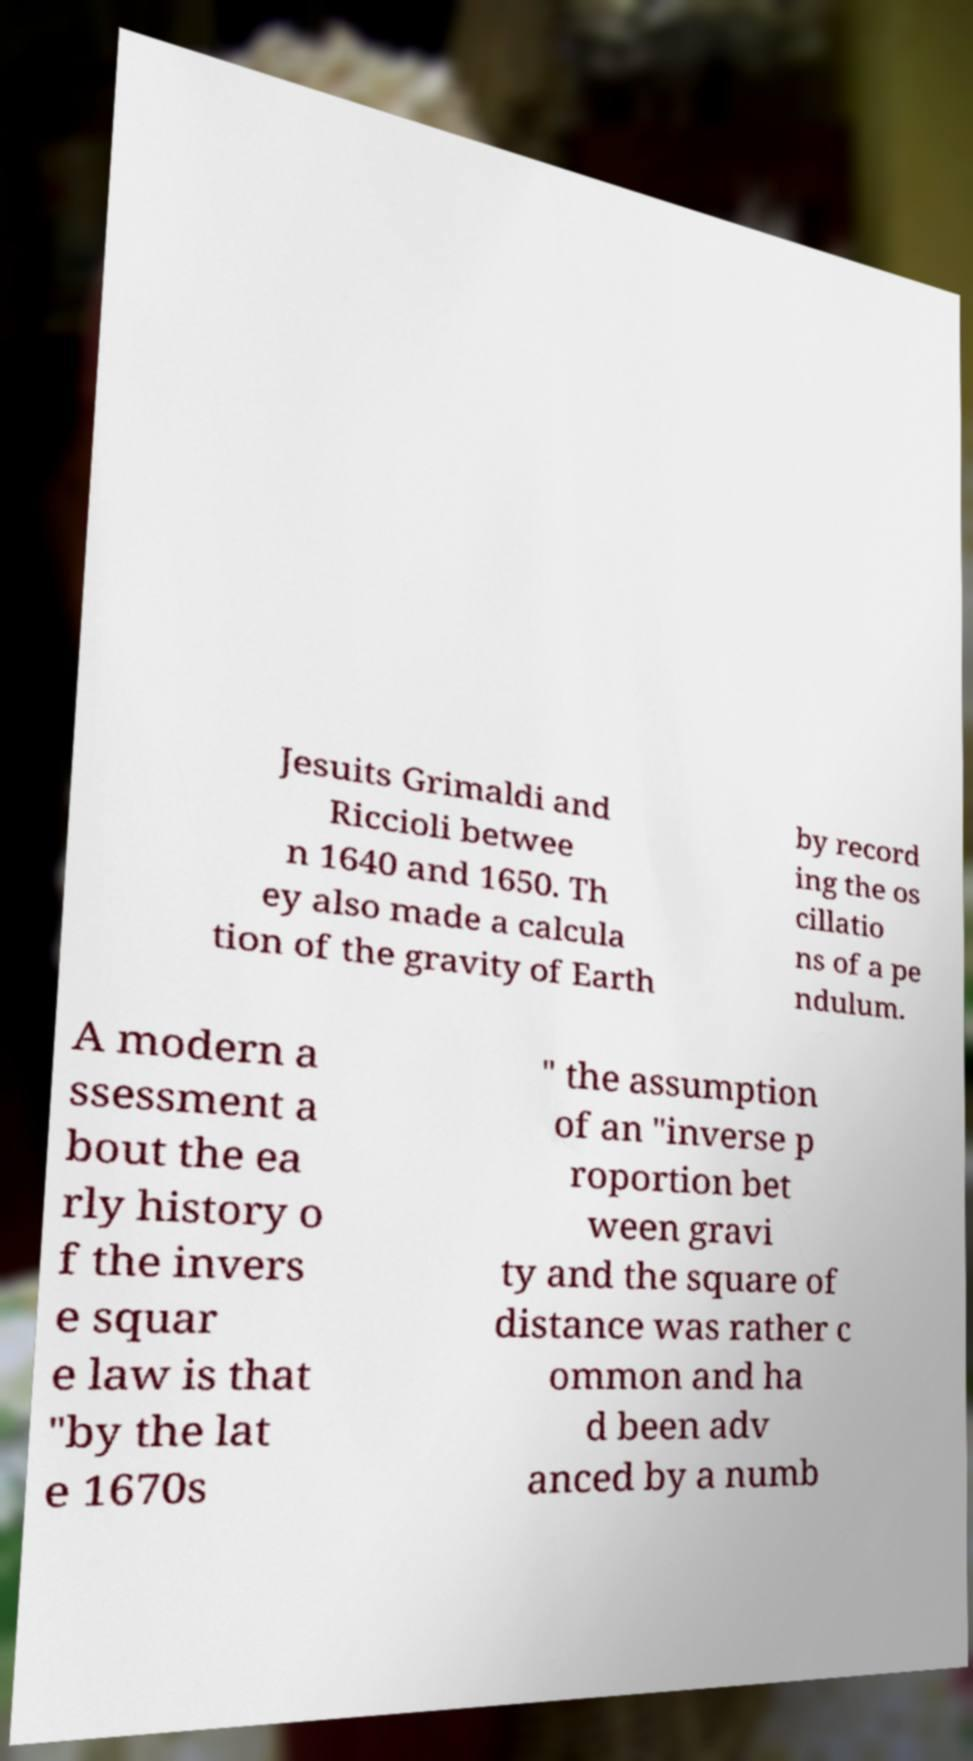Please identify and transcribe the text found in this image. Jesuits Grimaldi and Riccioli betwee n 1640 and 1650. Th ey also made a calcula tion of the gravity of Earth by record ing the os cillatio ns of a pe ndulum. A modern a ssessment a bout the ea rly history o f the invers e squar e law is that "by the lat e 1670s " the assumption of an "inverse p roportion bet ween gravi ty and the square of distance was rather c ommon and ha d been adv anced by a numb 